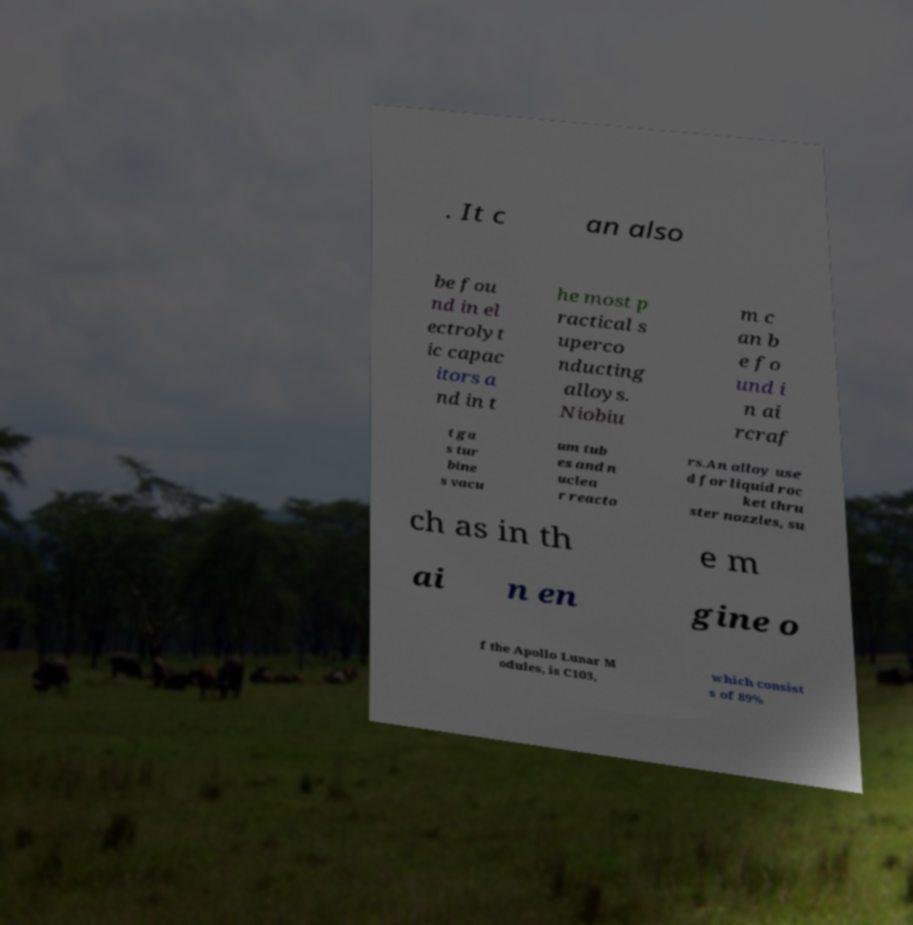Please identify and transcribe the text found in this image. . It c an also be fou nd in el ectrolyt ic capac itors a nd in t he most p ractical s uperco nducting alloys. Niobiu m c an b e fo und i n ai rcraf t ga s tur bine s vacu um tub es and n uclea r reacto rs.An alloy use d for liquid roc ket thru ster nozzles, su ch as in th e m ai n en gine o f the Apollo Lunar M odules, is C103, which consist s of 89% 